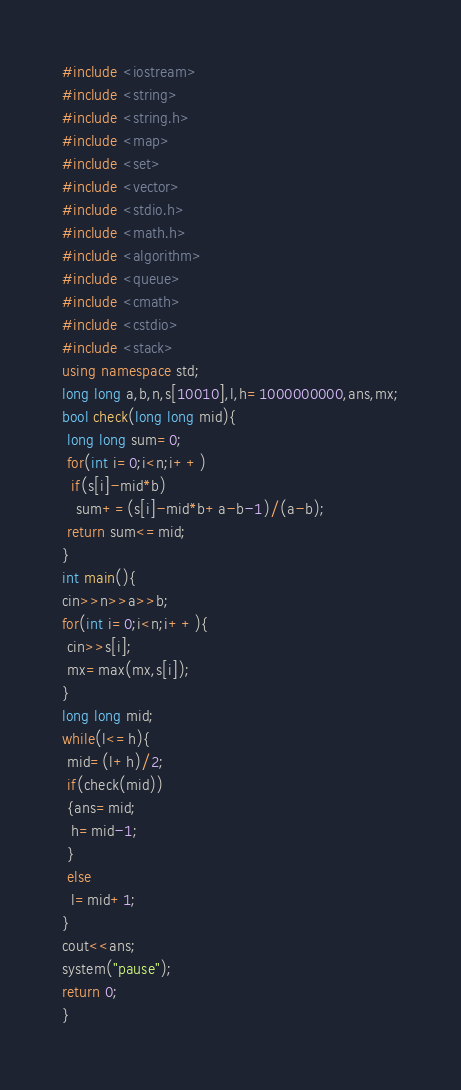<code> <loc_0><loc_0><loc_500><loc_500><_C++_>#include <iostream>
#include <string>
#include <string.h>
#include <map>
#include <set>
#include <vector>
#include <stdio.h>
#include <math.h>
#include <algorithm>
#include <queue>
#include <cmath>
#include <cstdio>
#include <stack>
using namespace std;
long long a,b,n,s[10010],l,h=1000000000,ans,mx;
bool check(long long mid){
 long long sum=0;
 for(int i=0;i<n;i++)
  if(s[i]-mid*b)
   sum+=(s[i]-mid*b+a-b-1)/(a-b);
 return sum<=mid;
}
int main(){
cin>>n>>a>>b;
for(int i=0;i<n;i++){
 cin>>s[i];
 mx=max(mx,s[i]);
}
long long mid;
while(l<=h){
 mid=(l+h)/2;
 if(check(mid))
 {ans=mid;
  h=mid-1;
 }
 else
  l=mid+1;
}
cout<<ans;
system("pause");
return 0;
}</code> 